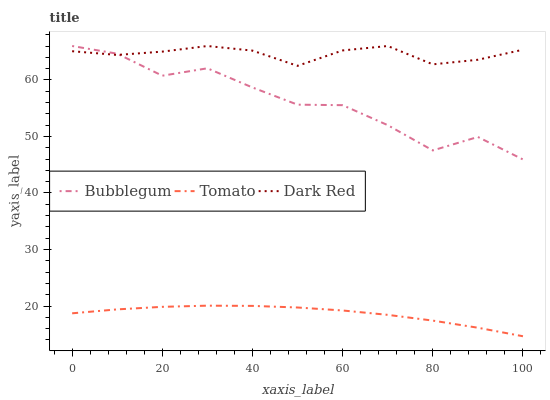Does Tomato have the minimum area under the curve?
Answer yes or no. Yes. Does Dark Red have the maximum area under the curve?
Answer yes or no. Yes. Does Bubblegum have the minimum area under the curve?
Answer yes or no. No. Does Bubblegum have the maximum area under the curve?
Answer yes or no. No. Is Tomato the smoothest?
Answer yes or no. Yes. Is Bubblegum the roughest?
Answer yes or no. Yes. Is Dark Red the smoothest?
Answer yes or no. No. Is Dark Red the roughest?
Answer yes or no. No. Does Bubblegum have the lowest value?
Answer yes or no. No. Does Bubblegum have the highest value?
Answer yes or no. Yes. Is Tomato less than Dark Red?
Answer yes or no. Yes. Is Bubblegum greater than Tomato?
Answer yes or no. Yes. Does Dark Red intersect Bubblegum?
Answer yes or no. Yes. Is Dark Red less than Bubblegum?
Answer yes or no. No. Is Dark Red greater than Bubblegum?
Answer yes or no. No. Does Tomato intersect Dark Red?
Answer yes or no. No. 